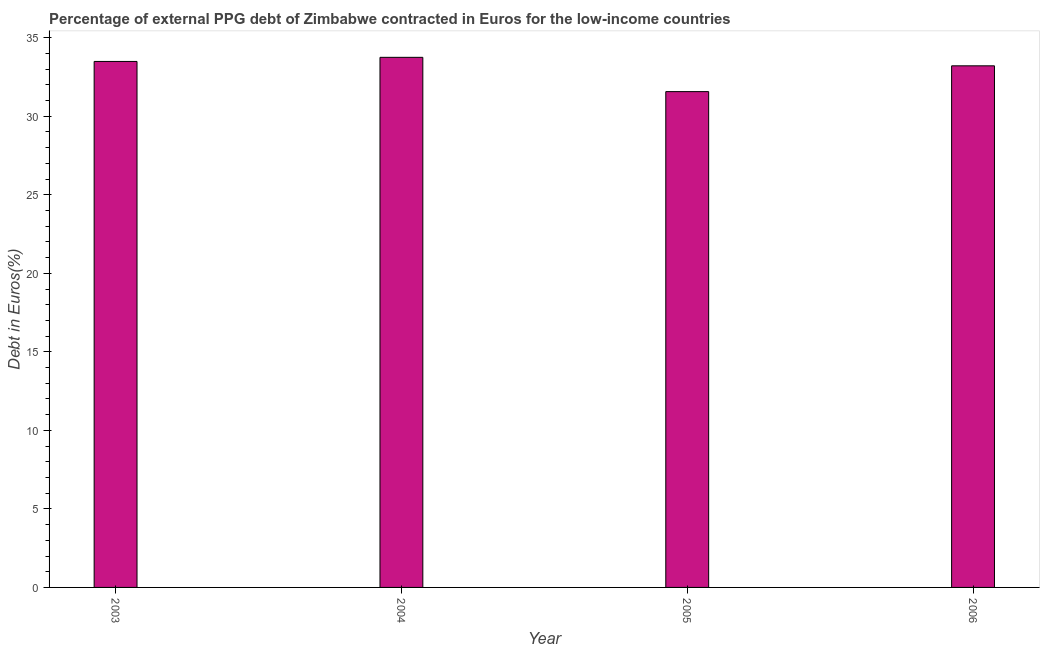Does the graph contain any zero values?
Give a very brief answer. No. What is the title of the graph?
Provide a short and direct response. Percentage of external PPG debt of Zimbabwe contracted in Euros for the low-income countries. What is the label or title of the X-axis?
Your answer should be compact. Year. What is the label or title of the Y-axis?
Ensure brevity in your answer.  Debt in Euros(%). What is the currency composition of ppg debt in 2004?
Offer a very short reply. 33.75. Across all years, what is the maximum currency composition of ppg debt?
Provide a succinct answer. 33.75. Across all years, what is the minimum currency composition of ppg debt?
Keep it short and to the point. 31.57. What is the sum of the currency composition of ppg debt?
Ensure brevity in your answer.  132.02. What is the difference between the currency composition of ppg debt in 2003 and 2005?
Ensure brevity in your answer.  1.92. What is the average currency composition of ppg debt per year?
Your response must be concise. 33.01. What is the median currency composition of ppg debt?
Your answer should be very brief. 33.35. Do a majority of the years between 2003 and 2006 (inclusive) have currency composition of ppg debt greater than 23 %?
Ensure brevity in your answer.  Yes. Is the currency composition of ppg debt in 2004 less than that in 2005?
Make the answer very short. No. Is the difference between the currency composition of ppg debt in 2003 and 2005 greater than the difference between any two years?
Provide a succinct answer. No. What is the difference between the highest and the second highest currency composition of ppg debt?
Make the answer very short. 0.26. Is the sum of the currency composition of ppg debt in 2005 and 2006 greater than the maximum currency composition of ppg debt across all years?
Provide a short and direct response. Yes. What is the difference between the highest and the lowest currency composition of ppg debt?
Keep it short and to the point. 2.18. How many bars are there?
Provide a short and direct response. 4. Are all the bars in the graph horizontal?
Offer a terse response. No. What is the difference between two consecutive major ticks on the Y-axis?
Give a very brief answer. 5. What is the Debt in Euros(%) in 2003?
Your response must be concise. 33.49. What is the Debt in Euros(%) in 2004?
Offer a terse response. 33.75. What is the Debt in Euros(%) in 2005?
Your answer should be very brief. 31.57. What is the Debt in Euros(%) of 2006?
Provide a succinct answer. 33.21. What is the difference between the Debt in Euros(%) in 2003 and 2004?
Ensure brevity in your answer.  -0.26. What is the difference between the Debt in Euros(%) in 2003 and 2005?
Give a very brief answer. 1.92. What is the difference between the Debt in Euros(%) in 2003 and 2006?
Your answer should be very brief. 0.28. What is the difference between the Debt in Euros(%) in 2004 and 2005?
Your response must be concise. 2.18. What is the difference between the Debt in Euros(%) in 2004 and 2006?
Ensure brevity in your answer.  0.54. What is the difference between the Debt in Euros(%) in 2005 and 2006?
Make the answer very short. -1.64. What is the ratio of the Debt in Euros(%) in 2003 to that in 2005?
Provide a short and direct response. 1.06. What is the ratio of the Debt in Euros(%) in 2004 to that in 2005?
Provide a succinct answer. 1.07. What is the ratio of the Debt in Euros(%) in 2005 to that in 2006?
Provide a short and direct response. 0.95. 